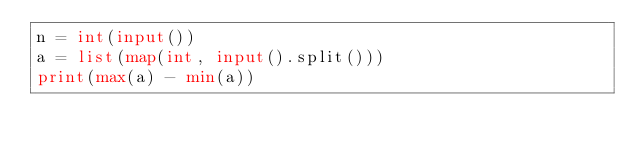Convert code to text. <code><loc_0><loc_0><loc_500><loc_500><_Python_>n = int(input())
a = list(map(int, input().split()))
print(max(a) - min(a))</code> 